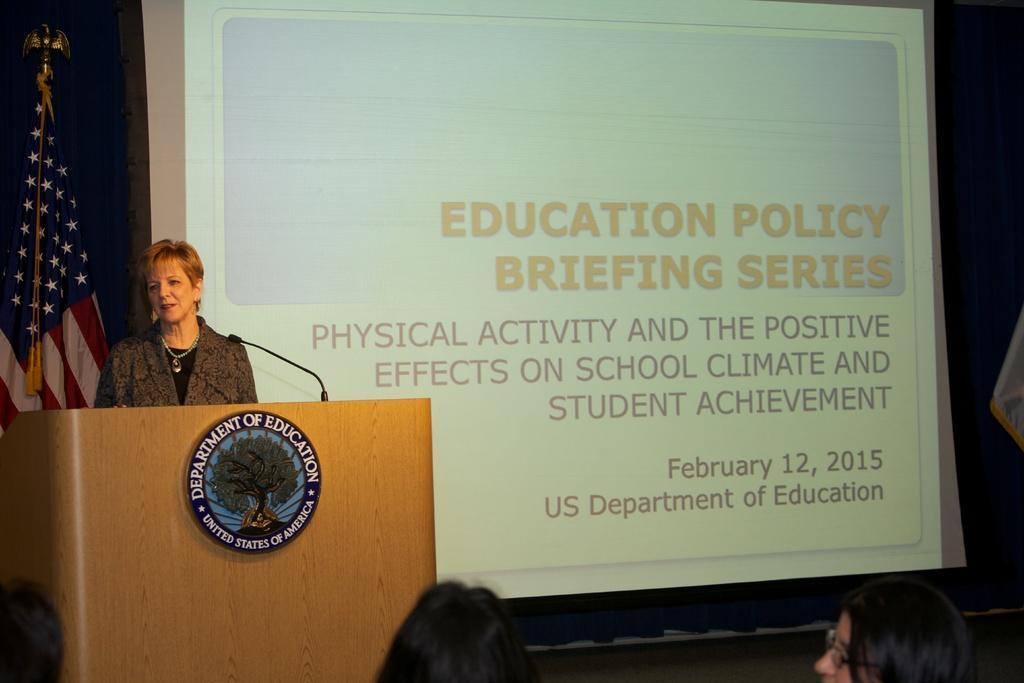Describe this image in one or two sentences. On the left side of the image, we can see a woman is standing behind the wooden podium. Here we can see a board and microphones. Background we can see flag, screen and curtain. At the bottom of the image, we can see heads of few people. 